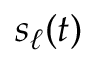<formula> <loc_0><loc_0><loc_500><loc_500>s _ { \ell } ( t )</formula> 